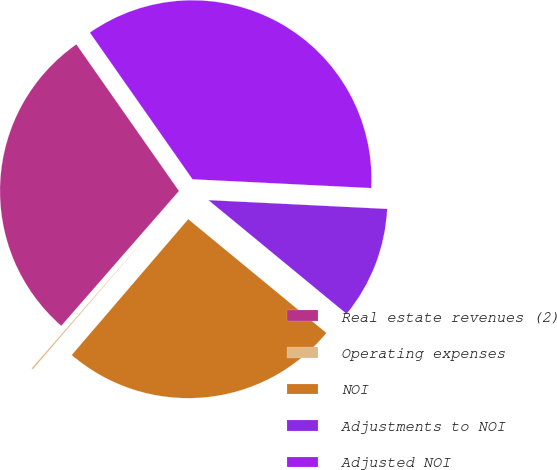<chart> <loc_0><loc_0><loc_500><loc_500><pie_chart><fcel>Real estate revenues (2)<fcel>Operating expenses<fcel>NOI<fcel>Adjustments to NOI<fcel>Adjusted NOI<nl><fcel>28.86%<fcel>0.14%<fcel>25.32%<fcel>10.18%<fcel>35.5%<nl></chart> 